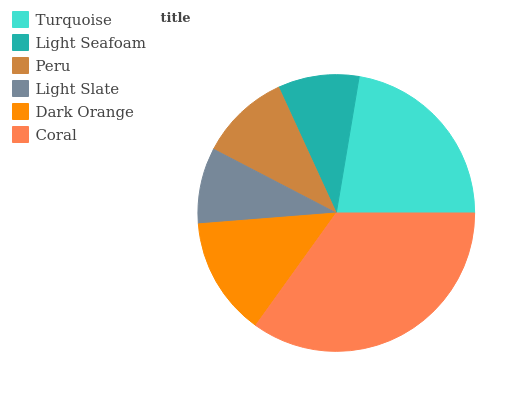Is Light Slate the minimum?
Answer yes or no. Yes. Is Coral the maximum?
Answer yes or no. Yes. Is Light Seafoam the minimum?
Answer yes or no. No. Is Light Seafoam the maximum?
Answer yes or no. No. Is Turquoise greater than Light Seafoam?
Answer yes or no. Yes. Is Light Seafoam less than Turquoise?
Answer yes or no. Yes. Is Light Seafoam greater than Turquoise?
Answer yes or no. No. Is Turquoise less than Light Seafoam?
Answer yes or no. No. Is Dark Orange the high median?
Answer yes or no. Yes. Is Peru the low median?
Answer yes or no. Yes. Is Light Seafoam the high median?
Answer yes or no. No. Is Light Slate the low median?
Answer yes or no. No. 